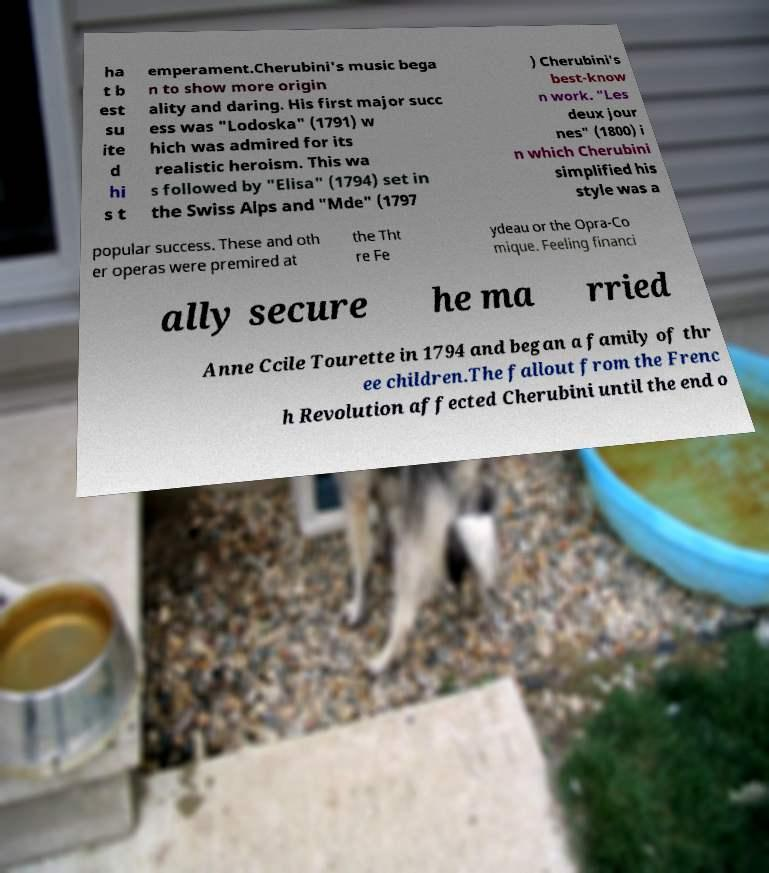I need the written content from this picture converted into text. Can you do that? ha t b est su ite d hi s t emperament.Cherubini's music bega n to show more origin ality and daring. His first major succ ess was "Lodoska" (1791) w hich was admired for its realistic heroism. This wa s followed by "Elisa" (1794) set in the Swiss Alps and "Mde" (1797 ) Cherubini's best-know n work. "Les deux jour nes" (1800) i n which Cherubini simplified his style was a popular success. These and oth er operas were premired at the Tht re Fe ydeau or the Opra-Co mique. Feeling financi ally secure he ma rried Anne Ccile Tourette in 1794 and began a family of thr ee children.The fallout from the Frenc h Revolution affected Cherubini until the end o 